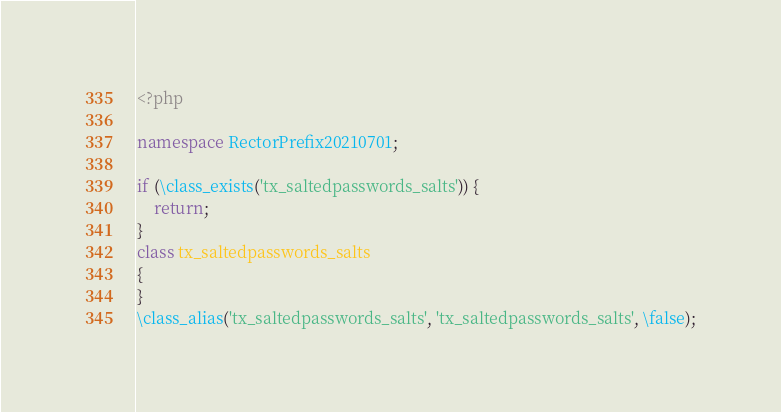Convert code to text. <code><loc_0><loc_0><loc_500><loc_500><_PHP_><?php

namespace RectorPrefix20210701;

if (\class_exists('tx_saltedpasswords_salts')) {
    return;
}
class tx_saltedpasswords_salts
{
}
\class_alias('tx_saltedpasswords_salts', 'tx_saltedpasswords_salts', \false);
</code> 